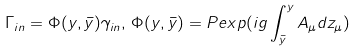Convert formula to latex. <formula><loc_0><loc_0><loc_500><loc_500>\Gamma _ { i n } = \Phi ( y , \bar { y } ) \gamma _ { i n } , \, \Phi ( y , \bar { y } ) = P e x p ( i g \int ^ { y } _ { \bar { y } } A _ { \mu } d z _ { \mu } )</formula> 